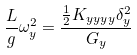<formula> <loc_0><loc_0><loc_500><loc_500>\frac { L } { g } \omega _ { y } ^ { 2 } = \frac { \frac { 1 } { 2 } K _ { y y y y } \delta _ { y } ^ { 2 } } { G _ { y } }</formula> 